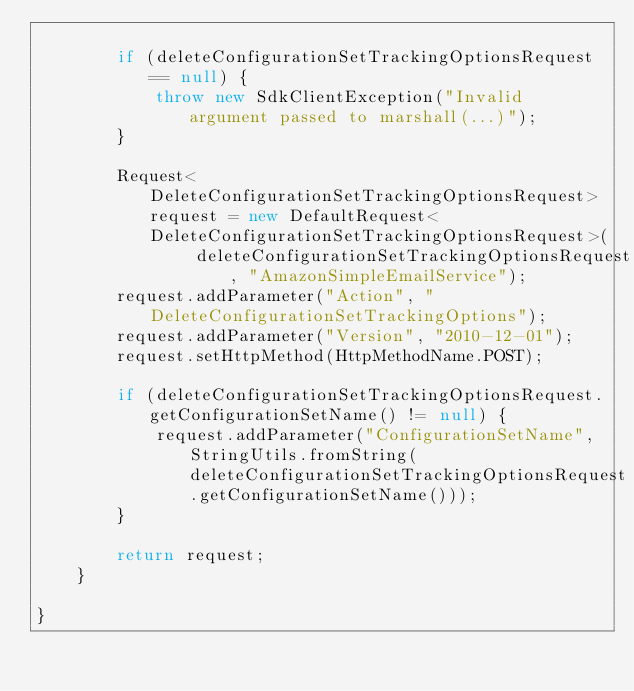Convert code to text. <code><loc_0><loc_0><loc_500><loc_500><_Java_>
        if (deleteConfigurationSetTrackingOptionsRequest == null) {
            throw new SdkClientException("Invalid argument passed to marshall(...)");
        }

        Request<DeleteConfigurationSetTrackingOptionsRequest> request = new DefaultRequest<DeleteConfigurationSetTrackingOptionsRequest>(
                deleteConfigurationSetTrackingOptionsRequest, "AmazonSimpleEmailService");
        request.addParameter("Action", "DeleteConfigurationSetTrackingOptions");
        request.addParameter("Version", "2010-12-01");
        request.setHttpMethod(HttpMethodName.POST);

        if (deleteConfigurationSetTrackingOptionsRequest.getConfigurationSetName() != null) {
            request.addParameter("ConfigurationSetName", StringUtils.fromString(deleteConfigurationSetTrackingOptionsRequest.getConfigurationSetName()));
        }

        return request;
    }

}
</code> 